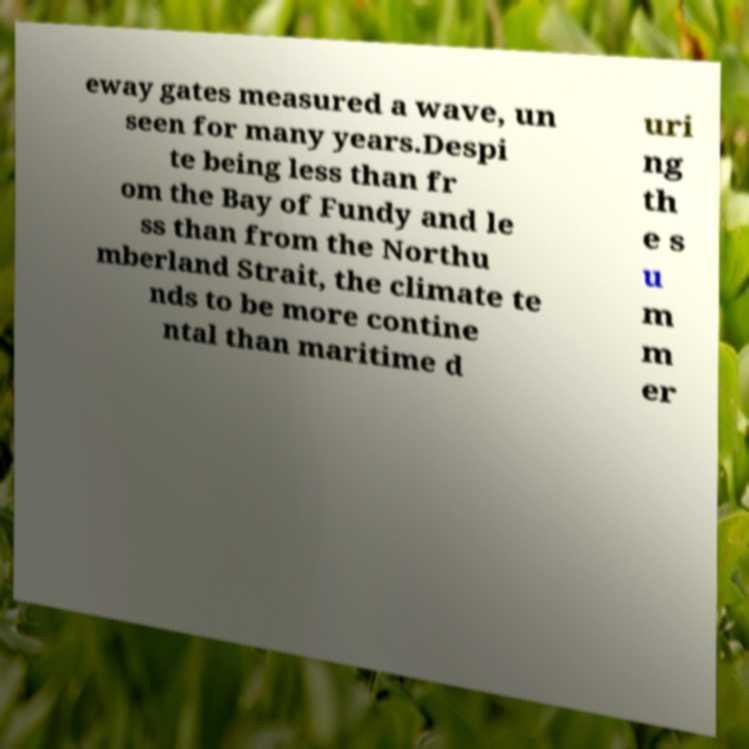Please identify and transcribe the text found in this image. eway gates measured a wave, un seen for many years.Despi te being less than fr om the Bay of Fundy and le ss than from the Northu mberland Strait, the climate te nds to be more contine ntal than maritime d uri ng th e s u m m er 